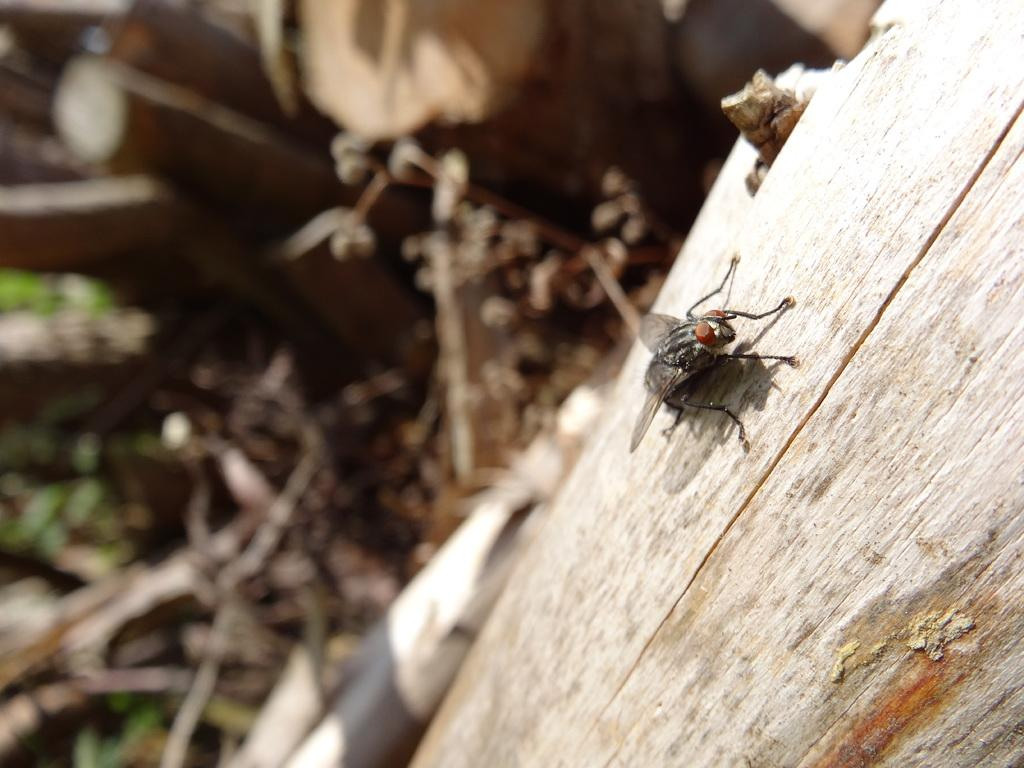What is on the trunk in the image? There is a fly on a trunk in the image. What else can be seen on the ground in the image? There are stocks on the ground in the image. How many mice are involved in the kissing scene in the image? There is no kissing scene or mice present in the image. What type of animal can be seen interacting with the fly on the trunk? There is no animal interacting with the fly on the trunk in the image; only the fly is present. 